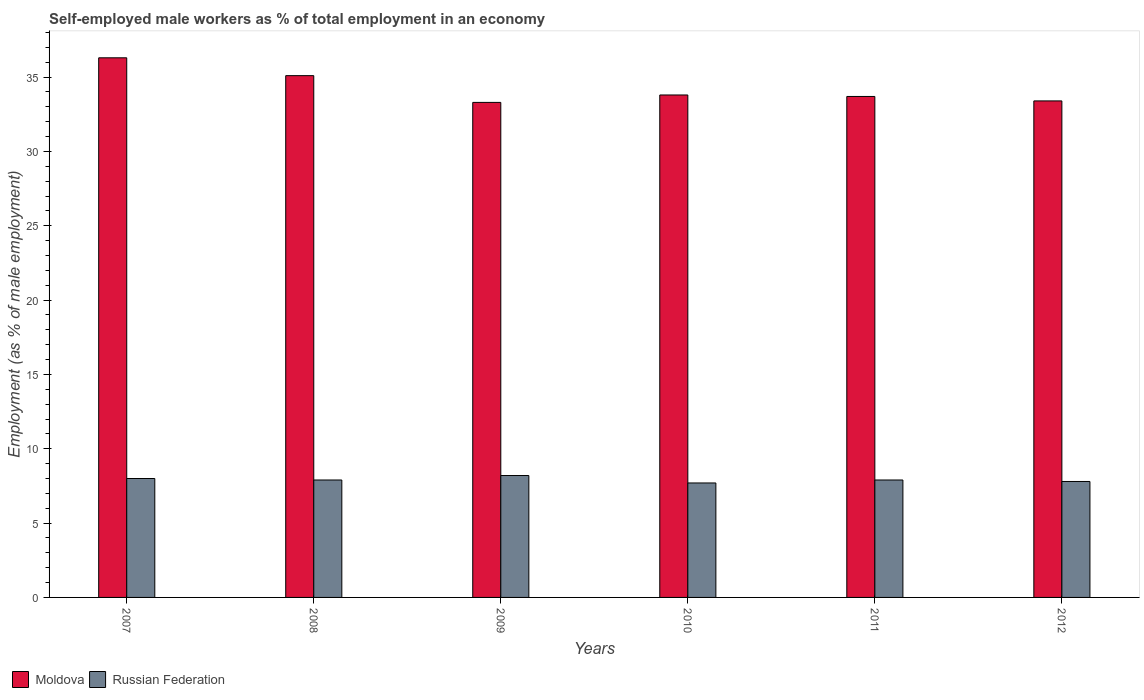Are the number of bars per tick equal to the number of legend labels?
Make the answer very short. Yes. Are the number of bars on each tick of the X-axis equal?
Offer a very short reply. Yes. How many bars are there on the 1st tick from the left?
Provide a short and direct response. 2. What is the percentage of self-employed male workers in Moldova in 2009?
Keep it short and to the point. 33.3. Across all years, what is the maximum percentage of self-employed male workers in Moldova?
Your answer should be very brief. 36.3. Across all years, what is the minimum percentage of self-employed male workers in Russian Federation?
Provide a short and direct response. 7.7. In which year was the percentage of self-employed male workers in Russian Federation maximum?
Your answer should be very brief. 2009. What is the total percentage of self-employed male workers in Russian Federation in the graph?
Provide a short and direct response. 47.5. What is the difference between the percentage of self-employed male workers in Russian Federation in 2009 and that in 2012?
Offer a terse response. 0.4. What is the difference between the percentage of self-employed male workers in Moldova in 2010 and the percentage of self-employed male workers in Russian Federation in 2012?
Offer a terse response. 26. What is the average percentage of self-employed male workers in Moldova per year?
Make the answer very short. 34.27. In the year 2012, what is the difference between the percentage of self-employed male workers in Russian Federation and percentage of self-employed male workers in Moldova?
Ensure brevity in your answer.  -25.6. In how many years, is the percentage of self-employed male workers in Moldova greater than 6 %?
Make the answer very short. 6. What is the ratio of the percentage of self-employed male workers in Moldova in 2007 to that in 2010?
Provide a short and direct response. 1.07. Is the difference between the percentage of self-employed male workers in Russian Federation in 2009 and 2010 greater than the difference between the percentage of self-employed male workers in Moldova in 2009 and 2010?
Offer a very short reply. Yes. What is the difference between the highest and the second highest percentage of self-employed male workers in Moldova?
Offer a terse response. 1.2. What is the difference between the highest and the lowest percentage of self-employed male workers in Russian Federation?
Provide a short and direct response. 0.5. What does the 2nd bar from the left in 2011 represents?
Your answer should be very brief. Russian Federation. What does the 2nd bar from the right in 2008 represents?
Your response must be concise. Moldova. How many bars are there?
Make the answer very short. 12. Are all the bars in the graph horizontal?
Give a very brief answer. No. Does the graph contain any zero values?
Offer a very short reply. No. Where does the legend appear in the graph?
Offer a terse response. Bottom left. How many legend labels are there?
Your answer should be very brief. 2. What is the title of the graph?
Make the answer very short. Self-employed male workers as % of total employment in an economy. Does "Turkey" appear as one of the legend labels in the graph?
Keep it short and to the point. No. What is the label or title of the X-axis?
Ensure brevity in your answer.  Years. What is the label or title of the Y-axis?
Your answer should be very brief. Employment (as % of male employment). What is the Employment (as % of male employment) in Moldova in 2007?
Your response must be concise. 36.3. What is the Employment (as % of male employment) of Moldova in 2008?
Keep it short and to the point. 35.1. What is the Employment (as % of male employment) in Russian Federation in 2008?
Offer a terse response. 7.9. What is the Employment (as % of male employment) in Moldova in 2009?
Make the answer very short. 33.3. What is the Employment (as % of male employment) of Russian Federation in 2009?
Provide a short and direct response. 8.2. What is the Employment (as % of male employment) in Moldova in 2010?
Your answer should be compact. 33.8. What is the Employment (as % of male employment) of Russian Federation in 2010?
Make the answer very short. 7.7. What is the Employment (as % of male employment) of Moldova in 2011?
Provide a succinct answer. 33.7. What is the Employment (as % of male employment) of Russian Federation in 2011?
Give a very brief answer. 7.9. What is the Employment (as % of male employment) of Moldova in 2012?
Provide a succinct answer. 33.4. What is the Employment (as % of male employment) of Russian Federation in 2012?
Give a very brief answer. 7.8. Across all years, what is the maximum Employment (as % of male employment) in Moldova?
Provide a short and direct response. 36.3. Across all years, what is the maximum Employment (as % of male employment) in Russian Federation?
Keep it short and to the point. 8.2. Across all years, what is the minimum Employment (as % of male employment) of Moldova?
Keep it short and to the point. 33.3. Across all years, what is the minimum Employment (as % of male employment) in Russian Federation?
Offer a terse response. 7.7. What is the total Employment (as % of male employment) in Moldova in the graph?
Your answer should be very brief. 205.6. What is the total Employment (as % of male employment) of Russian Federation in the graph?
Your response must be concise. 47.5. What is the difference between the Employment (as % of male employment) in Russian Federation in 2007 and that in 2008?
Give a very brief answer. 0.1. What is the difference between the Employment (as % of male employment) in Russian Federation in 2007 and that in 2011?
Provide a short and direct response. 0.1. What is the difference between the Employment (as % of male employment) in Russian Federation in 2007 and that in 2012?
Provide a succinct answer. 0.2. What is the difference between the Employment (as % of male employment) of Russian Federation in 2008 and that in 2010?
Provide a short and direct response. 0.2. What is the difference between the Employment (as % of male employment) of Russian Federation in 2008 and that in 2011?
Provide a succinct answer. 0. What is the difference between the Employment (as % of male employment) of Moldova in 2008 and that in 2012?
Your response must be concise. 1.7. What is the difference between the Employment (as % of male employment) in Russian Federation in 2008 and that in 2012?
Your answer should be compact. 0.1. What is the difference between the Employment (as % of male employment) of Moldova in 2009 and that in 2010?
Give a very brief answer. -0.5. What is the difference between the Employment (as % of male employment) of Russian Federation in 2009 and that in 2010?
Give a very brief answer. 0.5. What is the difference between the Employment (as % of male employment) of Moldova in 2009 and that in 2012?
Give a very brief answer. -0.1. What is the difference between the Employment (as % of male employment) in Russian Federation in 2009 and that in 2012?
Provide a short and direct response. 0.4. What is the difference between the Employment (as % of male employment) in Moldova in 2010 and that in 2011?
Offer a terse response. 0.1. What is the difference between the Employment (as % of male employment) in Moldova in 2010 and that in 2012?
Provide a succinct answer. 0.4. What is the difference between the Employment (as % of male employment) of Russian Federation in 2010 and that in 2012?
Keep it short and to the point. -0.1. What is the difference between the Employment (as % of male employment) in Russian Federation in 2011 and that in 2012?
Offer a very short reply. 0.1. What is the difference between the Employment (as % of male employment) of Moldova in 2007 and the Employment (as % of male employment) of Russian Federation in 2008?
Offer a terse response. 28.4. What is the difference between the Employment (as % of male employment) in Moldova in 2007 and the Employment (as % of male employment) in Russian Federation in 2009?
Offer a very short reply. 28.1. What is the difference between the Employment (as % of male employment) in Moldova in 2007 and the Employment (as % of male employment) in Russian Federation in 2010?
Ensure brevity in your answer.  28.6. What is the difference between the Employment (as % of male employment) in Moldova in 2007 and the Employment (as % of male employment) in Russian Federation in 2011?
Offer a very short reply. 28.4. What is the difference between the Employment (as % of male employment) of Moldova in 2008 and the Employment (as % of male employment) of Russian Federation in 2009?
Provide a short and direct response. 26.9. What is the difference between the Employment (as % of male employment) of Moldova in 2008 and the Employment (as % of male employment) of Russian Federation in 2010?
Provide a succinct answer. 27.4. What is the difference between the Employment (as % of male employment) of Moldova in 2008 and the Employment (as % of male employment) of Russian Federation in 2011?
Give a very brief answer. 27.2. What is the difference between the Employment (as % of male employment) of Moldova in 2008 and the Employment (as % of male employment) of Russian Federation in 2012?
Offer a terse response. 27.3. What is the difference between the Employment (as % of male employment) in Moldova in 2009 and the Employment (as % of male employment) in Russian Federation in 2010?
Your response must be concise. 25.6. What is the difference between the Employment (as % of male employment) in Moldova in 2009 and the Employment (as % of male employment) in Russian Federation in 2011?
Make the answer very short. 25.4. What is the difference between the Employment (as % of male employment) of Moldova in 2010 and the Employment (as % of male employment) of Russian Federation in 2011?
Provide a succinct answer. 25.9. What is the difference between the Employment (as % of male employment) in Moldova in 2011 and the Employment (as % of male employment) in Russian Federation in 2012?
Make the answer very short. 25.9. What is the average Employment (as % of male employment) in Moldova per year?
Provide a succinct answer. 34.27. What is the average Employment (as % of male employment) in Russian Federation per year?
Offer a terse response. 7.92. In the year 2007, what is the difference between the Employment (as % of male employment) in Moldova and Employment (as % of male employment) in Russian Federation?
Ensure brevity in your answer.  28.3. In the year 2008, what is the difference between the Employment (as % of male employment) of Moldova and Employment (as % of male employment) of Russian Federation?
Make the answer very short. 27.2. In the year 2009, what is the difference between the Employment (as % of male employment) of Moldova and Employment (as % of male employment) of Russian Federation?
Make the answer very short. 25.1. In the year 2010, what is the difference between the Employment (as % of male employment) of Moldova and Employment (as % of male employment) of Russian Federation?
Offer a very short reply. 26.1. In the year 2011, what is the difference between the Employment (as % of male employment) of Moldova and Employment (as % of male employment) of Russian Federation?
Ensure brevity in your answer.  25.8. In the year 2012, what is the difference between the Employment (as % of male employment) of Moldova and Employment (as % of male employment) of Russian Federation?
Your response must be concise. 25.6. What is the ratio of the Employment (as % of male employment) in Moldova in 2007 to that in 2008?
Offer a terse response. 1.03. What is the ratio of the Employment (as % of male employment) of Russian Federation in 2007 to that in 2008?
Your response must be concise. 1.01. What is the ratio of the Employment (as % of male employment) of Moldova in 2007 to that in 2009?
Give a very brief answer. 1.09. What is the ratio of the Employment (as % of male employment) of Russian Federation in 2007 to that in 2009?
Your answer should be compact. 0.98. What is the ratio of the Employment (as % of male employment) of Moldova in 2007 to that in 2010?
Offer a very short reply. 1.07. What is the ratio of the Employment (as % of male employment) in Russian Federation in 2007 to that in 2010?
Give a very brief answer. 1.04. What is the ratio of the Employment (as % of male employment) in Moldova in 2007 to that in 2011?
Give a very brief answer. 1.08. What is the ratio of the Employment (as % of male employment) of Russian Federation in 2007 to that in 2011?
Your response must be concise. 1.01. What is the ratio of the Employment (as % of male employment) of Moldova in 2007 to that in 2012?
Give a very brief answer. 1.09. What is the ratio of the Employment (as % of male employment) of Russian Federation in 2007 to that in 2012?
Your answer should be very brief. 1.03. What is the ratio of the Employment (as % of male employment) in Moldova in 2008 to that in 2009?
Provide a succinct answer. 1.05. What is the ratio of the Employment (as % of male employment) of Russian Federation in 2008 to that in 2009?
Make the answer very short. 0.96. What is the ratio of the Employment (as % of male employment) in Russian Federation in 2008 to that in 2010?
Your answer should be compact. 1.03. What is the ratio of the Employment (as % of male employment) in Moldova in 2008 to that in 2011?
Provide a short and direct response. 1.04. What is the ratio of the Employment (as % of male employment) in Russian Federation in 2008 to that in 2011?
Offer a very short reply. 1. What is the ratio of the Employment (as % of male employment) in Moldova in 2008 to that in 2012?
Give a very brief answer. 1.05. What is the ratio of the Employment (as % of male employment) in Russian Federation in 2008 to that in 2012?
Give a very brief answer. 1.01. What is the ratio of the Employment (as % of male employment) of Moldova in 2009 to that in 2010?
Your answer should be very brief. 0.99. What is the ratio of the Employment (as % of male employment) in Russian Federation in 2009 to that in 2010?
Make the answer very short. 1.06. What is the ratio of the Employment (as % of male employment) of Russian Federation in 2009 to that in 2011?
Your response must be concise. 1.04. What is the ratio of the Employment (as % of male employment) of Russian Federation in 2009 to that in 2012?
Your answer should be compact. 1.05. What is the ratio of the Employment (as % of male employment) in Moldova in 2010 to that in 2011?
Your answer should be very brief. 1. What is the ratio of the Employment (as % of male employment) of Russian Federation in 2010 to that in 2011?
Your response must be concise. 0.97. What is the ratio of the Employment (as % of male employment) of Moldova in 2010 to that in 2012?
Your answer should be compact. 1.01. What is the ratio of the Employment (as % of male employment) of Russian Federation in 2010 to that in 2012?
Provide a succinct answer. 0.99. What is the ratio of the Employment (as % of male employment) of Moldova in 2011 to that in 2012?
Provide a succinct answer. 1.01. What is the ratio of the Employment (as % of male employment) in Russian Federation in 2011 to that in 2012?
Your response must be concise. 1.01. What is the difference between the highest and the second highest Employment (as % of male employment) in Moldova?
Your answer should be compact. 1.2. What is the difference between the highest and the lowest Employment (as % of male employment) in Moldova?
Keep it short and to the point. 3. What is the difference between the highest and the lowest Employment (as % of male employment) of Russian Federation?
Offer a very short reply. 0.5. 